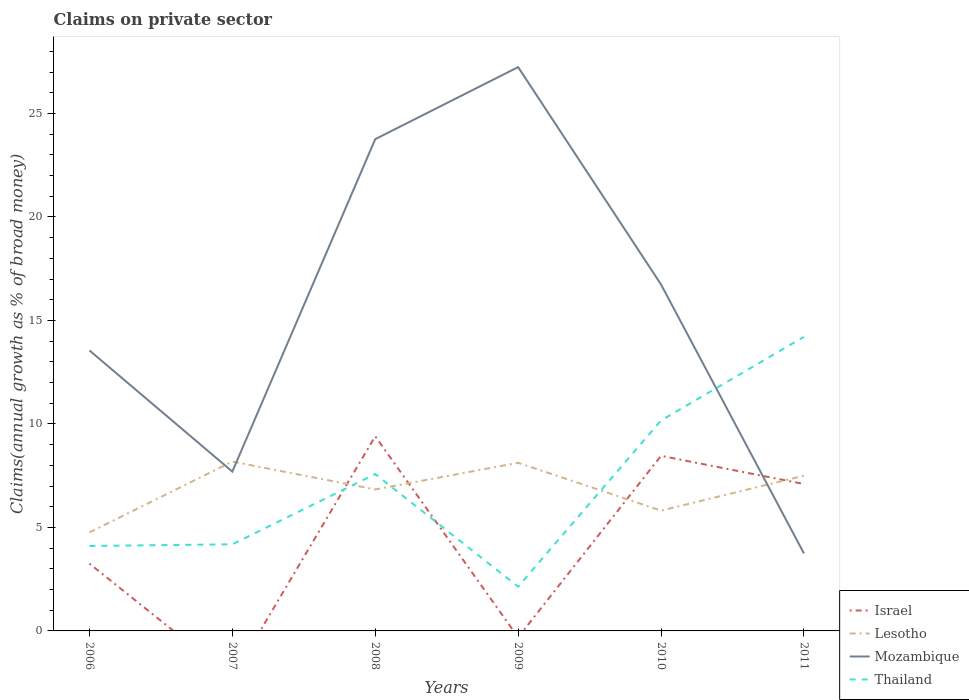Does the line corresponding to Thailand intersect with the line corresponding to Lesotho?
Ensure brevity in your answer.  Yes. Is the number of lines equal to the number of legend labels?
Keep it short and to the point. No. Across all years, what is the maximum percentage of broad money claimed on private sector in Thailand?
Provide a short and direct response. 2.14. What is the total percentage of broad money claimed on private sector in Thailand in the graph?
Provide a short and direct response. -4.04. What is the difference between the highest and the second highest percentage of broad money claimed on private sector in Lesotho?
Your answer should be very brief. 3.42. Is the percentage of broad money claimed on private sector in Lesotho strictly greater than the percentage of broad money claimed on private sector in Israel over the years?
Give a very brief answer. No. How many lines are there?
Give a very brief answer. 4. What is the difference between two consecutive major ticks on the Y-axis?
Offer a terse response. 5. How are the legend labels stacked?
Offer a very short reply. Vertical. What is the title of the graph?
Provide a succinct answer. Claims on private sector. What is the label or title of the Y-axis?
Offer a terse response. Claims(annual growth as % of broad money). What is the Claims(annual growth as % of broad money) in Israel in 2006?
Your answer should be very brief. 3.25. What is the Claims(annual growth as % of broad money) of Lesotho in 2006?
Offer a very short reply. 4.76. What is the Claims(annual growth as % of broad money) of Mozambique in 2006?
Your answer should be compact. 13.55. What is the Claims(annual growth as % of broad money) in Thailand in 2006?
Your response must be concise. 4.1. What is the Claims(annual growth as % of broad money) in Lesotho in 2007?
Your answer should be compact. 8.18. What is the Claims(annual growth as % of broad money) in Mozambique in 2007?
Provide a short and direct response. 7.7. What is the Claims(annual growth as % of broad money) of Thailand in 2007?
Ensure brevity in your answer.  4.18. What is the Claims(annual growth as % of broad money) in Israel in 2008?
Make the answer very short. 9.4. What is the Claims(annual growth as % of broad money) in Lesotho in 2008?
Your answer should be very brief. 6.83. What is the Claims(annual growth as % of broad money) of Mozambique in 2008?
Make the answer very short. 23.76. What is the Claims(annual growth as % of broad money) in Thailand in 2008?
Give a very brief answer. 7.58. What is the Claims(annual growth as % of broad money) in Lesotho in 2009?
Make the answer very short. 8.12. What is the Claims(annual growth as % of broad money) of Mozambique in 2009?
Provide a short and direct response. 27.24. What is the Claims(annual growth as % of broad money) in Thailand in 2009?
Your answer should be very brief. 2.14. What is the Claims(annual growth as % of broad money) of Israel in 2010?
Offer a very short reply. 8.46. What is the Claims(annual growth as % of broad money) in Lesotho in 2010?
Your answer should be very brief. 5.81. What is the Claims(annual growth as % of broad money) of Mozambique in 2010?
Keep it short and to the point. 16.74. What is the Claims(annual growth as % of broad money) of Thailand in 2010?
Offer a very short reply. 10.17. What is the Claims(annual growth as % of broad money) in Israel in 2011?
Make the answer very short. 7.1. What is the Claims(annual growth as % of broad money) in Lesotho in 2011?
Offer a terse response. 7.5. What is the Claims(annual growth as % of broad money) in Mozambique in 2011?
Offer a terse response. 3.75. What is the Claims(annual growth as % of broad money) of Thailand in 2011?
Keep it short and to the point. 14.21. Across all years, what is the maximum Claims(annual growth as % of broad money) of Israel?
Keep it short and to the point. 9.4. Across all years, what is the maximum Claims(annual growth as % of broad money) in Lesotho?
Ensure brevity in your answer.  8.18. Across all years, what is the maximum Claims(annual growth as % of broad money) in Mozambique?
Your response must be concise. 27.24. Across all years, what is the maximum Claims(annual growth as % of broad money) in Thailand?
Provide a succinct answer. 14.21. Across all years, what is the minimum Claims(annual growth as % of broad money) in Israel?
Provide a succinct answer. 0. Across all years, what is the minimum Claims(annual growth as % of broad money) in Lesotho?
Provide a succinct answer. 4.76. Across all years, what is the minimum Claims(annual growth as % of broad money) of Mozambique?
Give a very brief answer. 3.75. Across all years, what is the minimum Claims(annual growth as % of broad money) in Thailand?
Provide a short and direct response. 2.14. What is the total Claims(annual growth as % of broad money) of Israel in the graph?
Offer a very short reply. 28.21. What is the total Claims(annual growth as % of broad money) of Lesotho in the graph?
Your response must be concise. 41.21. What is the total Claims(annual growth as % of broad money) of Mozambique in the graph?
Provide a short and direct response. 92.72. What is the total Claims(annual growth as % of broad money) in Thailand in the graph?
Your answer should be compact. 42.38. What is the difference between the Claims(annual growth as % of broad money) in Lesotho in 2006 and that in 2007?
Provide a succinct answer. -3.42. What is the difference between the Claims(annual growth as % of broad money) of Mozambique in 2006 and that in 2007?
Offer a terse response. 5.85. What is the difference between the Claims(annual growth as % of broad money) of Thailand in 2006 and that in 2007?
Provide a succinct answer. -0.08. What is the difference between the Claims(annual growth as % of broad money) of Israel in 2006 and that in 2008?
Your response must be concise. -6.15. What is the difference between the Claims(annual growth as % of broad money) of Lesotho in 2006 and that in 2008?
Your answer should be compact. -2.07. What is the difference between the Claims(annual growth as % of broad money) of Mozambique in 2006 and that in 2008?
Ensure brevity in your answer.  -10.21. What is the difference between the Claims(annual growth as % of broad money) in Thailand in 2006 and that in 2008?
Your answer should be very brief. -3.47. What is the difference between the Claims(annual growth as % of broad money) in Lesotho in 2006 and that in 2009?
Your response must be concise. -3.36. What is the difference between the Claims(annual growth as % of broad money) of Mozambique in 2006 and that in 2009?
Your answer should be very brief. -13.69. What is the difference between the Claims(annual growth as % of broad money) in Thailand in 2006 and that in 2009?
Your answer should be very brief. 1.96. What is the difference between the Claims(annual growth as % of broad money) in Israel in 2006 and that in 2010?
Provide a succinct answer. -5.21. What is the difference between the Claims(annual growth as % of broad money) in Lesotho in 2006 and that in 2010?
Make the answer very short. -1.05. What is the difference between the Claims(annual growth as % of broad money) of Mozambique in 2006 and that in 2010?
Your answer should be very brief. -3.19. What is the difference between the Claims(annual growth as % of broad money) of Thailand in 2006 and that in 2010?
Offer a terse response. -6.06. What is the difference between the Claims(annual growth as % of broad money) in Israel in 2006 and that in 2011?
Offer a very short reply. -3.85. What is the difference between the Claims(annual growth as % of broad money) of Lesotho in 2006 and that in 2011?
Offer a very short reply. -2.74. What is the difference between the Claims(annual growth as % of broad money) in Mozambique in 2006 and that in 2011?
Offer a very short reply. 9.8. What is the difference between the Claims(annual growth as % of broad money) in Thailand in 2006 and that in 2011?
Provide a succinct answer. -10.1. What is the difference between the Claims(annual growth as % of broad money) of Lesotho in 2007 and that in 2008?
Make the answer very short. 1.35. What is the difference between the Claims(annual growth as % of broad money) in Mozambique in 2007 and that in 2008?
Your answer should be compact. -16.06. What is the difference between the Claims(annual growth as % of broad money) of Thailand in 2007 and that in 2008?
Provide a short and direct response. -3.39. What is the difference between the Claims(annual growth as % of broad money) in Lesotho in 2007 and that in 2009?
Offer a very short reply. 0.06. What is the difference between the Claims(annual growth as % of broad money) of Mozambique in 2007 and that in 2009?
Provide a short and direct response. -19.54. What is the difference between the Claims(annual growth as % of broad money) of Thailand in 2007 and that in 2009?
Provide a succinct answer. 2.04. What is the difference between the Claims(annual growth as % of broad money) in Lesotho in 2007 and that in 2010?
Provide a short and direct response. 2.37. What is the difference between the Claims(annual growth as % of broad money) of Mozambique in 2007 and that in 2010?
Your answer should be compact. -9.04. What is the difference between the Claims(annual growth as % of broad money) in Thailand in 2007 and that in 2010?
Offer a terse response. -5.98. What is the difference between the Claims(annual growth as % of broad money) of Lesotho in 2007 and that in 2011?
Your answer should be compact. 0.68. What is the difference between the Claims(annual growth as % of broad money) in Mozambique in 2007 and that in 2011?
Your response must be concise. 3.95. What is the difference between the Claims(annual growth as % of broad money) of Thailand in 2007 and that in 2011?
Offer a terse response. -10.02. What is the difference between the Claims(annual growth as % of broad money) in Lesotho in 2008 and that in 2009?
Ensure brevity in your answer.  -1.29. What is the difference between the Claims(annual growth as % of broad money) of Mozambique in 2008 and that in 2009?
Provide a succinct answer. -3.48. What is the difference between the Claims(annual growth as % of broad money) in Thailand in 2008 and that in 2009?
Provide a short and direct response. 5.44. What is the difference between the Claims(annual growth as % of broad money) of Israel in 2008 and that in 2010?
Offer a terse response. 0.94. What is the difference between the Claims(annual growth as % of broad money) in Lesotho in 2008 and that in 2010?
Offer a terse response. 1.02. What is the difference between the Claims(annual growth as % of broad money) of Mozambique in 2008 and that in 2010?
Offer a very short reply. 7.02. What is the difference between the Claims(annual growth as % of broad money) of Thailand in 2008 and that in 2010?
Provide a succinct answer. -2.59. What is the difference between the Claims(annual growth as % of broad money) in Israel in 2008 and that in 2011?
Offer a very short reply. 2.3. What is the difference between the Claims(annual growth as % of broad money) in Lesotho in 2008 and that in 2011?
Give a very brief answer. -0.66. What is the difference between the Claims(annual growth as % of broad money) in Mozambique in 2008 and that in 2011?
Give a very brief answer. 20.01. What is the difference between the Claims(annual growth as % of broad money) in Thailand in 2008 and that in 2011?
Ensure brevity in your answer.  -6.63. What is the difference between the Claims(annual growth as % of broad money) in Lesotho in 2009 and that in 2010?
Offer a very short reply. 2.31. What is the difference between the Claims(annual growth as % of broad money) of Mozambique in 2009 and that in 2010?
Offer a very short reply. 10.5. What is the difference between the Claims(annual growth as % of broad money) of Thailand in 2009 and that in 2010?
Your answer should be very brief. -8.03. What is the difference between the Claims(annual growth as % of broad money) of Lesotho in 2009 and that in 2011?
Offer a terse response. 0.62. What is the difference between the Claims(annual growth as % of broad money) in Mozambique in 2009 and that in 2011?
Your answer should be very brief. 23.49. What is the difference between the Claims(annual growth as % of broad money) in Thailand in 2009 and that in 2011?
Your response must be concise. -12.07. What is the difference between the Claims(annual growth as % of broad money) in Israel in 2010 and that in 2011?
Your response must be concise. 1.36. What is the difference between the Claims(annual growth as % of broad money) in Lesotho in 2010 and that in 2011?
Offer a terse response. -1.69. What is the difference between the Claims(annual growth as % of broad money) of Mozambique in 2010 and that in 2011?
Provide a short and direct response. 12.99. What is the difference between the Claims(annual growth as % of broad money) in Thailand in 2010 and that in 2011?
Offer a terse response. -4.04. What is the difference between the Claims(annual growth as % of broad money) of Israel in 2006 and the Claims(annual growth as % of broad money) of Lesotho in 2007?
Keep it short and to the point. -4.93. What is the difference between the Claims(annual growth as % of broad money) of Israel in 2006 and the Claims(annual growth as % of broad money) of Mozambique in 2007?
Give a very brief answer. -4.45. What is the difference between the Claims(annual growth as % of broad money) in Israel in 2006 and the Claims(annual growth as % of broad money) in Thailand in 2007?
Provide a short and direct response. -0.93. What is the difference between the Claims(annual growth as % of broad money) of Lesotho in 2006 and the Claims(annual growth as % of broad money) of Mozambique in 2007?
Make the answer very short. -2.94. What is the difference between the Claims(annual growth as % of broad money) of Lesotho in 2006 and the Claims(annual growth as % of broad money) of Thailand in 2007?
Your answer should be very brief. 0.58. What is the difference between the Claims(annual growth as % of broad money) in Mozambique in 2006 and the Claims(annual growth as % of broad money) in Thailand in 2007?
Provide a short and direct response. 9.37. What is the difference between the Claims(annual growth as % of broad money) in Israel in 2006 and the Claims(annual growth as % of broad money) in Lesotho in 2008?
Offer a very short reply. -3.58. What is the difference between the Claims(annual growth as % of broad money) of Israel in 2006 and the Claims(annual growth as % of broad money) of Mozambique in 2008?
Ensure brevity in your answer.  -20.5. What is the difference between the Claims(annual growth as % of broad money) of Israel in 2006 and the Claims(annual growth as % of broad money) of Thailand in 2008?
Your response must be concise. -4.33. What is the difference between the Claims(annual growth as % of broad money) of Lesotho in 2006 and the Claims(annual growth as % of broad money) of Mozambique in 2008?
Give a very brief answer. -19. What is the difference between the Claims(annual growth as % of broad money) in Lesotho in 2006 and the Claims(annual growth as % of broad money) in Thailand in 2008?
Ensure brevity in your answer.  -2.82. What is the difference between the Claims(annual growth as % of broad money) in Mozambique in 2006 and the Claims(annual growth as % of broad money) in Thailand in 2008?
Offer a very short reply. 5.97. What is the difference between the Claims(annual growth as % of broad money) in Israel in 2006 and the Claims(annual growth as % of broad money) in Lesotho in 2009?
Offer a very short reply. -4.87. What is the difference between the Claims(annual growth as % of broad money) of Israel in 2006 and the Claims(annual growth as % of broad money) of Mozambique in 2009?
Give a very brief answer. -23.98. What is the difference between the Claims(annual growth as % of broad money) of Israel in 2006 and the Claims(annual growth as % of broad money) of Thailand in 2009?
Ensure brevity in your answer.  1.11. What is the difference between the Claims(annual growth as % of broad money) of Lesotho in 2006 and the Claims(annual growth as % of broad money) of Mozambique in 2009?
Your answer should be compact. -22.48. What is the difference between the Claims(annual growth as % of broad money) in Lesotho in 2006 and the Claims(annual growth as % of broad money) in Thailand in 2009?
Keep it short and to the point. 2.62. What is the difference between the Claims(annual growth as % of broad money) in Mozambique in 2006 and the Claims(annual growth as % of broad money) in Thailand in 2009?
Provide a succinct answer. 11.41. What is the difference between the Claims(annual growth as % of broad money) in Israel in 2006 and the Claims(annual growth as % of broad money) in Lesotho in 2010?
Your answer should be compact. -2.56. What is the difference between the Claims(annual growth as % of broad money) of Israel in 2006 and the Claims(annual growth as % of broad money) of Mozambique in 2010?
Give a very brief answer. -13.48. What is the difference between the Claims(annual growth as % of broad money) of Israel in 2006 and the Claims(annual growth as % of broad money) of Thailand in 2010?
Offer a terse response. -6.91. What is the difference between the Claims(annual growth as % of broad money) in Lesotho in 2006 and the Claims(annual growth as % of broad money) in Mozambique in 2010?
Your response must be concise. -11.98. What is the difference between the Claims(annual growth as % of broad money) in Lesotho in 2006 and the Claims(annual growth as % of broad money) in Thailand in 2010?
Your response must be concise. -5.41. What is the difference between the Claims(annual growth as % of broad money) of Mozambique in 2006 and the Claims(annual growth as % of broad money) of Thailand in 2010?
Give a very brief answer. 3.38. What is the difference between the Claims(annual growth as % of broad money) in Israel in 2006 and the Claims(annual growth as % of broad money) in Lesotho in 2011?
Ensure brevity in your answer.  -4.25. What is the difference between the Claims(annual growth as % of broad money) in Israel in 2006 and the Claims(annual growth as % of broad money) in Mozambique in 2011?
Your response must be concise. -0.49. What is the difference between the Claims(annual growth as % of broad money) of Israel in 2006 and the Claims(annual growth as % of broad money) of Thailand in 2011?
Provide a succinct answer. -10.96. What is the difference between the Claims(annual growth as % of broad money) of Lesotho in 2006 and the Claims(annual growth as % of broad money) of Mozambique in 2011?
Give a very brief answer. 1.01. What is the difference between the Claims(annual growth as % of broad money) of Lesotho in 2006 and the Claims(annual growth as % of broad money) of Thailand in 2011?
Give a very brief answer. -9.45. What is the difference between the Claims(annual growth as % of broad money) in Mozambique in 2006 and the Claims(annual growth as % of broad money) in Thailand in 2011?
Ensure brevity in your answer.  -0.66. What is the difference between the Claims(annual growth as % of broad money) of Lesotho in 2007 and the Claims(annual growth as % of broad money) of Mozambique in 2008?
Give a very brief answer. -15.58. What is the difference between the Claims(annual growth as % of broad money) in Lesotho in 2007 and the Claims(annual growth as % of broad money) in Thailand in 2008?
Your response must be concise. 0.6. What is the difference between the Claims(annual growth as % of broad money) of Mozambique in 2007 and the Claims(annual growth as % of broad money) of Thailand in 2008?
Your answer should be compact. 0.12. What is the difference between the Claims(annual growth as % of broad money) in Lesotho in 2007 and the Claims(annual growth as % of broad money) in Mozambique in 2009?
Provide a succinct answer. -19.06. What is the difference between the Claims(annual growth as % of broad money) of Lesotho in 2007 and the Claims(annual growth as % of broad money) of Thailand in 2009?
Your response must be concise. 6.04. What is the difference between the Claims(annual growth as % of broad money) in Mozambique in 2007 and the Claims(annual growth as % of broad money) in Thailand in 2009?
Offer a very short reply. 5.56. What is the difference between the Claims(annual growth as % of broad money) of Lesotho in 2007 and the Claims(annual growth as % of broad money) of Mozambique in 2010?
Keep it short and to the point. -8.55. What is the difference between the Claims(annual growth as % of broad money) in Lesotho in 2007 and the Claims(annual growth as % of broad money) in Thailand in 2010?
Offer a terse response. -1.99. What is the difference between the Claims(annual growth as % of broad money) of Mozambique in 2007 and the Claims(annual growth as % of broad money) of Thailand in 2010?
Give a very brief answer. -2.47. What is the difference between the Claims(annual growth as % of broad money) in Lesotho in 2007 and the Claims(annual growth as % of broad money) in Mozambique in 2011?
Ensure brevity in your answer.  4.44. What is the difference between the Claims(annual growth as % of broad money) in Lesotho in 2007 and the Claims(annual growth as % of broad money) in Thailand in 2011?
Your response must be concise. -6.03. What is the difference between the Claims(annual growth as % of broad money) of Mozambique in 2007 and the Claims(annual growth as % of broad money) of Thailand in 2011?
Ensure brevity in your answer.  -6.51. What is the difference between the Claims(annual growth as % of broad money) of Israel in 2008 and the Claims(annual growth as % of broad money) of Lesotho in 2009?
Provide a succinct answer. 1.28. What is the difference between the Claims(annual growth as % of broad money) of Israel in 2008 and the Claims(annual growth as % of broad money) of Mozambique in 2009?
Provide a short and direct response. -17.84. What is the difference between the Claims(annual growth as % of broad money) in Israel in 2008 and the Claims(annual growth as % of broad money) in Thailand in 2009?
Offer a terse response. 7.26. What is the difference between the Claims(annual growth as % of broad money) of Lesotho in 2008 and the Claims(annual growth as % of broad money) of Mozambique in 2009?
Provide a short and direct response. -20.4. What is the difference between the Claims(annual growth as % of broad money) in Lesotho in 2008 and the Claims(annual growth as % of broad money) in Thailand in 2009?
Provide a short and direct response. 4.69. What is the difference between the Claims(annual growth as % of broad money) of Mozambique in 2008 and the Claims(annual growth as % of broad money) of Thailand in 2009?
Provide a succinct answer. 21.62. What is the difference between the Claims(annual growth as % of broad money) in Israel in 2008 and the Claims(annual growth as % of broad money) in Lesotho in 2010?
Provide a succinct answer. 3.59. What is the difference between the Claims(annual growth as % of broad money) in Israel in 2008 and the Claims(annual growth as % of broad money) in Mozambique in 2010?
Make the answer very short. -7.33. What is the difference between the Claims(annual growth as % of broad money) of Israel in 2008 and the Claims(annual growth as % of broad money) of Thailand in 2010?
Make the answer very short. -0.77. What is the difference between the Claims(annual growth as % of broad money) of Lesotho in 2008 and the Claims(annual growth as % of broad money) of Mozambique in 2010?
Ensure brevity in your answer.  -9.9. What is the difference between the Claims(annual growth as % of broad money) of Lesotho in 2008 and the Claims(annual growth as % of broad money) of Thailand in 2010?
Offer a terse response. -3.33. What is the difference between the Claims(annual growth as % of broad money) of Mozambique in 2008 and the Claims(annual growth as % of broad money) of Thailand in 2010?
Keep it short and to the point. 13.59. What is the difference between the Claims(annual growth as % of broad money) in Israel in 2008 and the Claims(annual growth as % of broad money) in Lesotho in 2011?
Offer a very short reply. 1.9. What is the difference between the Claims(annual growth as % of broad money) of Israel in 2008 and the Claims(annual growth as % of broad money) of Mozambique in 2011?
Make the answer very short. 5.66. What is the difference between the Claims(annual growth as % of broad money) in Israel in 2008 and the Claims(annual growth as % of broad money) in Thailand in 2011?
Your response must be concise. -4.81. What is the difference between the Claims(annual growth as % of broad money) of Lesotho in 2008 and the Claims(annual growth as % of broad money) of Mozambique in 2011?
Provide a short and direct response. 3.09. What is the difference between the Claims(annual growth as % of broad money) of Lesotho in 2008 and the Claims(annual growth as % of broad money) of Thailand in 2011?
Make the answer very short. -7.37. What is the difference between the Claims(annual growth as % of broad money) of Mozambique in 2008 and the Claims(annual growth as % of broad money) of Thailand in 2011?
Provide a short and direct response. 9.55. What is the difference between the Claims(annual growth as % of broad money) in Lesotho in 2009 and the Claims(annual growth as % of broad money) in Mozambique in 2010?
Keep it short and to the point. -8.61. What is the difference between the Claims(annual growth as % of broad money) of Lesotho in 2009 and the Claims(annual growth as % of broad money) of Thailand in 2010?
Your answer should be compact. -2.04. What is the difference between the Claims(annual growth as % of broad money) in Mozambique in 2009 and the Claims(annual growth as % of broad money) in Thailand in 2010?
Provide a short and direct response. 17.07. What is the difference between the Claims(annual growth as % of broad money) of Lesotho in 2009 and the Claims(annual growth as % of broad money) of Mozambique in 2011?
Offer a terse response. 4.38. What is the difference between the Claims(annual growth as % of broad money) in Lesotho in 2009 and the Claims(annual growth as % of broad money) in Thailand in 2011?
Give a very brief answer. -6.08. What is the difference between the Claims(annual growth as % of broad money) in Mozambique in 2009 and the Claims(annual growth as % of broad money) in Thailand in 2011?
Provide a short and direct response. 13.03. What is the difference between the Claims(annual growth as % of broad money) in Israel in 2010 and the Claims(annual growth as % of broad money) in Lesotho in 2011?
Offer a terse response. 0.96. What is the difference between the Claims(annual growth as % of broad money) of Israel in 2010 and the Claims(annual growth as % of broad money) of Mozambique in 2011?
Provide a short and direct response. 4.71. What is the difference between the Claims(annual growth as % of broad money) of Israel in 2010 and the Claims(annual growth as % of broad money) of Thailand in 2011?
Your answer should be very brief. -5.75. What is the difference between the Claims(annual growth as % of broad money) in Lesotho in 2010 and the Claims(annual growth as % of broad money) in Mozambique in 2011?
Provide a succinct answer. 2.07. What is the difference between the Claims(annual growth as % of broad money) of Lesotho in 2010 and the Claims(annual growth as % of broad money) of Thailand in 2011?
Make the answer very short. -8.39. What is the difference between the Claims(annual growth as % of broad money) in Mozambique in 2010 and the Claims(annual growth as % of broad money) in Thailand in 2011?
Make the answer very short. 2.53. What is the average Claims(annual growth as % of broad money) of Israel per year?
Provide a short and direct response. 4.7. What is the average Claims(annual growth as % of broad money) of Lesotho per year?
Give a very brief answer. 6.87. What is the average Claims(annual growth as % of broad money) in Mozambique per year?
Your response must be concise. 15.45. What is the average Claims(annual growth as % of broad money) in Thailand per year?
Your answer should be very brief. 7.06. In the year 2006, what is the difference between the Claims(annual growth as % of broad money) of Israel and Claims(annual growth as % of broad money) of Lesotho?
Your response must be concise. -1.51. In the year 2006, what is the difference between the Claims(annual growth as % of broad money) of Israel and Claims(annual growth as % of broad money) of Mozambique?
Your answer should be very brief. -10.3. In the year 2006, what is the difference between the Claims(annual growth as % of broad money) of Israel and Claims(annual growth as % of broad money) of Thailand?
Your answer should be very brief. -0.85. In the year 2006, what is the difference between the Claims(annual growth as % of broad money) of Lesotho and Claims(annual growth as % of broad money) of Mozambique?
Your answer should be compact. -8.79. In the year 2006, what is the difference between the Claims(annual growth as % of broad money) in Lesotho and Claims(annual growth as % of broad money) in Thailand?
Offer a very short reply. 0.66. In the year 2006, what is the difference between the Claims(annual growth as % of broad money) of Mozambique and Claims(annual growth as % of broad money) of Thailand?
Make the answer very short. 9.45. In the year 2007, what is the difference between the Claims(annual growth as % of broad money) of Lesotho and Claims(annual growth as % of broad money) of Mozambique?
Offer a very short reply. 0.48. In the year 2007, what is the difference between the Claims(annual growth as % of broad money) of Lesotho and Claims(annual growth as % of broad money) of Thailand?
Keep it short and to the point. 4. In the year 2007, what is the difference between the Claims(annual growth as % of broad money) in Mozambique and Claims(annual growth as % of broad money) in Thailand?
Your answer should be very brief. 3.51. In the year 2008, what is the difference between the Claims(annual growth as % of broad money) of Israel and Claims(annual growth as % of broad money) of Lesotho?
Offer a terse response. 2.57. In the year 2008, what is the difference between the Claims(annual growth as % of broad money) in Israel and Claims(annual growth as % of broad money) in Mozambique?
Your response must be concise. -14.36. In the year 2008, what is the difference between the Claims(annual growth as % of broad money) in Israel and Claims(annual growth as % of broad money) in Thailand?
Your answer should be compact. 1.82. In the year 2008, what is the difference between the Claims(annual growth as % of broad money) in Lesotho and Claims(annual growth as % of broad money) in Mozambique?
Your answer should be compact. -16.92. In the year 2008, what is the difference between the Claims(annual growth as % of broad money) of Lesotho and Claims(annual growth as % of broad money) of Thailand?
Make the answer very short. -0.74. In the year 2008, what is the difference between the Claims(annual growth as % of broad money) in Mozambique and Claims(annual growth as % of broad money) in Thailand?
Your answer should be compact. 16.18. In the year 2009, what is the difference between the Claims(annual growth as % of broad money) of Lesotho and Claims(annual growth as % of broad money) of Mozambique?
Your response must be concise. -19.11. In the year 2009, what is the difference between the Claims(annual growth as % of broad money) of Lesotho and Claims(annual growth as % of broad money) of Thailand?
Offer a very short reply. 5.98. In the year 2009, what is the difference between the Claims(annual growth as % of broad money) in Mozambique and Claims(annual growth as % of broad money) in Thailand?
Your answer should be compact. 25.1. In the year 2010, what is the difference between the Claims(annual growth as % of broad money) in Israel and Claims(annual growth as % of broad money) in Lesotho?
Provide a short and direct response. 2.65. In the year 2010, what is the difference between the Claims(annual growth as % of broad money) of Israel and Claims(annual growth as % of broad money) of Mozambique?
Your answer should be very brief. -8.28. In the year 2010, what is the difference between the Claims(annual growth as % of broad money) in Israel and Claims(annual growth as % of broad money) in Thailand?
Make the answer very short. -1.71. In the year 2010, what is the difference between the Claims(annual growth as % of broad money) of Lesotho and Claims(annual growth as % of broad money) of Mozambique?
Ensure brevity in your answer.  -10.92. In the year 2010, what is the difference between the Claims(annual growth as % of broad money) in Lesotho and Claims(annual growth as % of broad money) in Thailand?
Your answer should be compact. -4.35. In the year 2010, what is the difference between the Claims(annual growth as % of broad money) of Mozambique and Claims(annual growth as % of broad money) of Thailand?
Your answer should be compact. 6.57. In the year 2011, what is the difference between the Claims(annual growth as % of broad money) of Israel and Claims(annual growth as % of broad money) of Lesotho?
Ensure brevity in your answer.  -0.4. In the year 2011, what is the difference between the Claims(annual growth as % of broad money) in Israel and Claims(annual growth as % of broad money) in Mozambique?
Ensure brevity in your answer.  3.35. In the year 2011, what is the difference between the Claims(annual growth as % of broad money) of Israel and Claims(annual growth as % of broad money) of Thailand?
Your answer should be very brief. -7.11. In the year 2011, what is the difference between the Claims(annual growth as % of broad money) in Lesotho and Claims(annual growth as % of broad money) in Mozambique?
Make the answer very short. 3.75. In the year 2011, what is the difference between the Claims(annual growth as % of broad money) in Lesotho and Claims(annual growth as % of broad money) in Thailand?
Your response must be concise. -6.71. In the year 2011, what is the difference between the Claims(annual growth as % of broad money) of Mozambique and Claims(annual growth as % of broad money) of Thailand?
Keep it short and to the point. -10.46. What is the ratio of the Claims(annual growth as % of broad money) of Lesotho in 2006 to that in 2007?
Provide a succinct answer. 0.58. What is the ratio of the Claims(annual growth as % of broad money) of Mozambique in 2006 to that in 2007?
Offer a terse response. 1.76. What is the ratio of the Claims(annual growth as % of broad money) in Thailand in 2006 to that in 2007?
Give a very brief answer. 0.98. What is the ratio of the Claims(annual growth as % of broad money) of Israel in 2006 to that in 2008?
Provide a succinct answer. 0.35. What is the ratio of the Claims(annual growth as % of broad money) of Lesotho in 2006 to that in 2008?
Provide a succinct answer. 0.7. What is the ratio of the Claims(annual growth as % of broad money) of Mozambique in 2006 to that in 2008?
Your answer should be very brief. 0.57. What is the ratio of the Claims(annual growth as % of broad money) in Thailand in 2006 to that in 2008?
Offer a terse response. 0.54. What is the ratio of the Claims(annual growth as % of broad money) of Lesotho in 2006 to that in 2009?
Offer a terse response. 0.59. What is the ratio of the Claims(annual growth as % of broad money) in Mozambique in 2006 to that in 2009?
Offer a terse response. 0.5. What is the ratio of the Claims(annual growth as % of broad money) in Thailand in 2006 to that in 2009?
Offer a terse response. 1.92. What is the ratio of the Claims(annual growth as % of broad money) of Israel in 2006 to that in 2010?
Your answer should be very brief. 0.38. What is the ratio of the Claims(annual growth as % of broad money) in Lesotho in 2006 to that in 2010?
Keep it short and to the point. 0.82. What is the ratio of the Claims(annual growth as % of broad money) of Mozambique in 2006 to that in 2010?
Ensure brevity in your answer.  0.81. What is the ratio of the Claims(annual growth as % of broad money) in Thailand in 2006 to that in 2010?
Your response must be concise. 0.4. What is the ratio of the Claims(annual growth as % of broad money) of Israel in 2006 to that in 2011?
Ensure brevity in your answer.  0.46. What is the ratio of the Claims(annual growth as % of broad money) in Lesotho in 2006 to that in 2011?
Give a very brief answer. 0.63. What is the ratio of the Claims(annual growth as % of broad money) of Mozambique in 2006 to that in 2011?
Ensure brevity in your answer.  3.62. What is the ratio of the Claims(annual growth as % of broad money) of Thailand in 2006 to that in 2011?
Your answer should be very brief. 0.29. What is the ratio of the Claims(annual growth as % of broad money) of Lesotho in 2007 to that in 2008?
Ensure brevity in your answer.  1.2. What is the ratio of the Claims(annual growth as % of broad money) in Mozambique in 2007 to that in 2008?
Your answer should be very brief. 0.32. What is the ratio of the Claims(annual growth as % of broad money) of Thailand in 2007 to that in 2008?
Provide a succinct answer. 0.55. What is the ratio of the Claims(annual growth as % of broad money) of Lesotho in 2007 to that in 2009?
Offer a terse response. 1.01. What is the ratio of the Claims(annual growth as % of broad money) in Mozambique in 2007 to that in 2009?
Your answer should be compact. 0.28. What is the ratio of the Claims(annual growth as % of broad money) in Thailand in 2007 to that in 2009?
Your response must be concise. 1.96. What is the ratio of the Claims(annual growth as % of broad money) in Lesotho in 2007 to that in 2010?
Your response must be concise. 1.41. What is the ratio of the Claims(annual growth as % of broad money) in Mozambique in 2007 to that in 2010?
Offer a very short reply. 0.46. What is the ratio of the Claims(annual growth as % of broad money) of Thailand in 2007 to that in 2010?
Provide a short and direct response. 0.41. What is the ratio of the Claims(annual growth as % of broad money) of Lesotho in 2007 to that in 2011?
Provide a succinct answer. 1.09. What is the ratio of the Claims(annual growth as % of broad money) of Mozambique in 2007 to that in 2011?
Give a very brief answer. 2.06. What is the ratio of the Claims(annual growth as % of broad money) of Thailand in 2007 to that in 2011?
Provide a succinct answer. 0.29. What is the ratio of the Claims(annual growth as % of broad money) in Lesotho in 2008 to that in 2009?
Your response must be concise. 0.84. What is the ratio of the Claims(annual growth as % of broad money) in Mozambique in 2008 to that in 2009?
Your response must be concise. 0.87. What is the ratio of the Claims(annual growth as % of broad money) in Thailand in 2008 to that in 2009?
Keep it short and to the point. 3.54. What is the ratio of the Claims(annual growth as % of broad money) in Israel in 2008 to that in 2010?
Offer a very short reply. 1.11. What is the ratio of the Claims(annual growth as % of broad money) in Lesotho in 2008 to that in 2010?
Keep it short and to the point. 1.18. What is the ratio of the Claims(annual growth as % of broad money) in Mozambique in 2008 to that in 2010?
Your response must be concise. 1.42. What is the ratio of the Claims(annual growth as % of broad money) of Thailand in 2008 to that in 2010?
Provide a succinct answer. 0.75. What is the ratio of the Claims(annual growth as % of broad money) of Israel in 2008 to that in 2011?
Ensure brevity in your answer.  1.32. What is the ratio of the Claims(annual growth as % of broad money) of Lesotho in 2008 to that in 2011?
Provide a short and direct response. 0.91. What is the ratio of the Claims(annual growth as % of broad money) in Mozambique in 2008 to that in 2011?
Give a very brief answer. 6.34. What is the ratio of the Claims(annual growth as % of broad money) in Thailand in 2008 to that in 2011?
Offer a very short reply. 0.53. What is the ratio of the Claims(annual growth as % of broad money) of Lesotho in 2009 to that in 2010?
Ensure brevity in your answer.  1.4. What is the ratio of the Claims(annual growth as % of broad money) in Mozambique in 2009 to that in 2010?
Offer a very short reply. 1.63. What is the ratio of the Claims(annual growth as % of broad money) in Thailand in 2009 to that in 2010?
Keep it short and to the point. 0.21. What is the ratio of the Claims(annual growth as % of broad money) in Lesotho in 2009 to that in 2011?
Keep it short and to the point. 1.08. What is the ratio of the Claims(annual growth as % of broad money) of Mozambique in 2009 to that in 2011?
Your response must be concise. 7.27. What is the ratio of the Claims(annual growth as % of broad money) of Thailand in 2009 to that in 2011?
Offer a very short reply. 0.15. What is the ratio of the Claims(annual growth as % of broad money) of Israel in 2010 to that in 2011?
Your response must be concise. 1.19. What is the ratio of the Claims(annual growth as % of broad money) of Lesotho in 2010 to that in 2011?
Offer a terse response. 0.78. What is the ratio of the Claims(annual growth as % of broad money) of Mozambique in 2010 to that in 2011?
Ensure brevity in your answer.  4.47. What is the ratio of the Claims(annual growth as % of broad money) in Thailand in 2010 to that in 2011?
Your answer should be very brief. 0.72. What is the difference between the highest and the second highest Claims(annual growth as % of broad money) in Israel?
Give a very brief answer. 0.94. What is the difference between the highest and the second highest Claims(annual growth as % of broad money) in Lesotho?
Give a very brief answer. 0.06. What is the difference between the highest and the second highest Claims(annual growth as % of broad money) of Mozambique?
Provide a succinct answer. 3.48. What is the difference between the highest and the second highest Claims(annual growth as % of broad money) of Thailand?
Give a very brief answer. 4.04. What is the difference between the highest and the lowest Claims(annual growth as % of broad money) of Israel?
Ensure brevity in your answer.  9.4. What is the difference between the highest and the lowest Claims(annual growth as % of broad money) of Lesotho?
Give a very brief answer. 3.42. What is the difference between the highest and the lowest Claims(annual growth as % of broad money) of Mozambique?
Offer a terse response. 23.49. What is the difference between the highest and the lowest Claims(annual growth as % of broad money) in Thailand?
Your response must be concise. 12.07. 